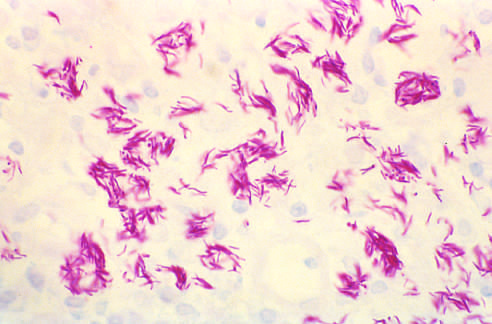re there inadequate t cells to mount a granulomatous response?
Answer the question using a single word or phrase. Yes 